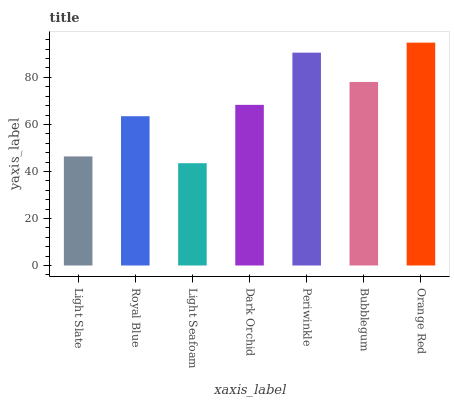Is Light Seafoam the minimum?
Answer yes or no. Yes. Is Orange Red the maximum?
Answer yes or no. Yes. Is Royal Blue the minimum?
Answer yes or no. No. Is Royal Blue the maximum?
Answer yes or no. No. Is Royal Blue greater than Light Slate?
Answer yes or no. Yes. Is Light Slate less than Royal Blue?
Answer yes or no. Yes. Is Light Slate greater than Royal Blue?
Answer yes or no. No. Is Royal Blue less than Light Slate?
Answer yes or no. No. Is Dark Orchid the high median?
Answer yes or no. Yes. Is Dark Orchid the low median?
Answer yes or no. Yes. Is Light Seafoam the high median?
Answer yes or no. No. Is Bubblegum the low median?
Answer yes or no. No. 